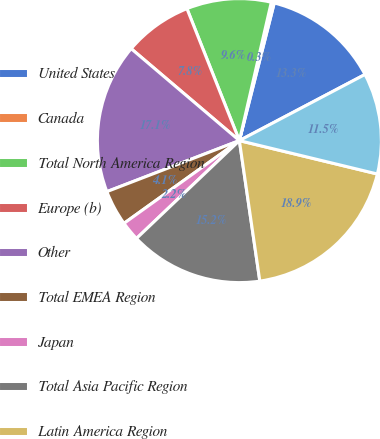<chart> <loc_0><loc_0><loc_500><loc_500><pie_chart><fcel>United States<fcel>Canada<fcel>Total North America Region<fcel>Europe (b)<fcel>Other<fcel>Total EMEA Region<fcel>Japan<fcel>Total Asia Pacific Region<fcel>Latin America Region<fcel>Total Worldwide Retail Sales<nl><fcel>13.34%<fcel>0.34%<fcel>9.63%<fcel>7.77%<fcel>17.06%<fcel>4.05%<fcel>2.2%<fcel>15.2%<fcel>18.92%<fcel>11.49%<nl></chart> 